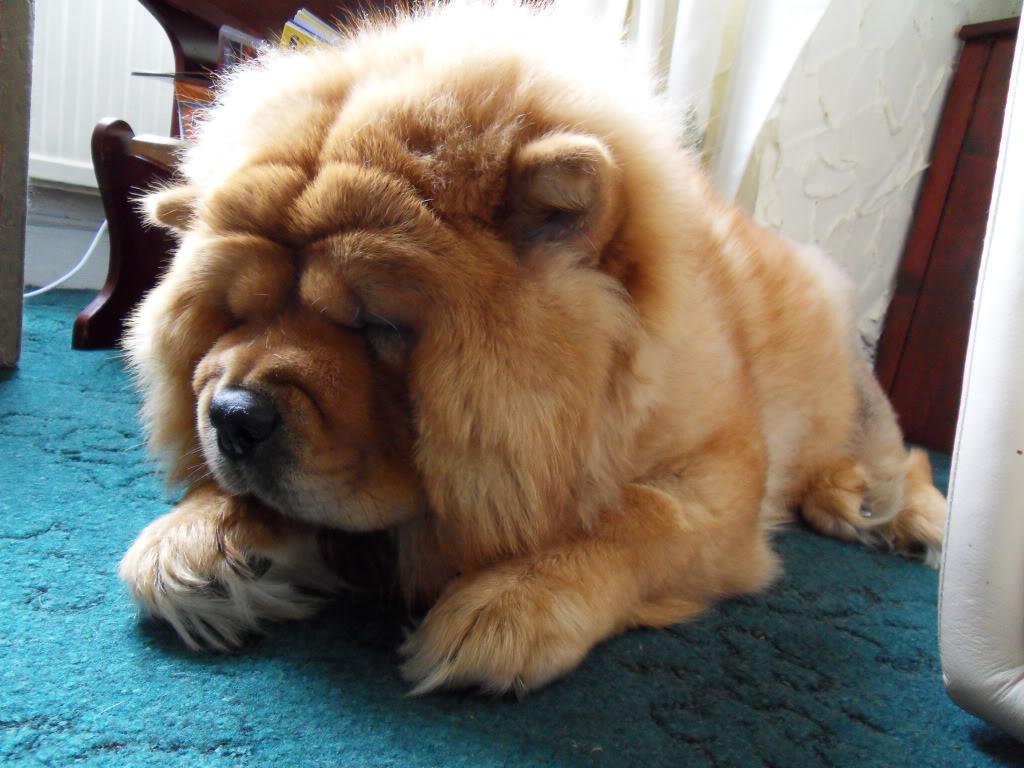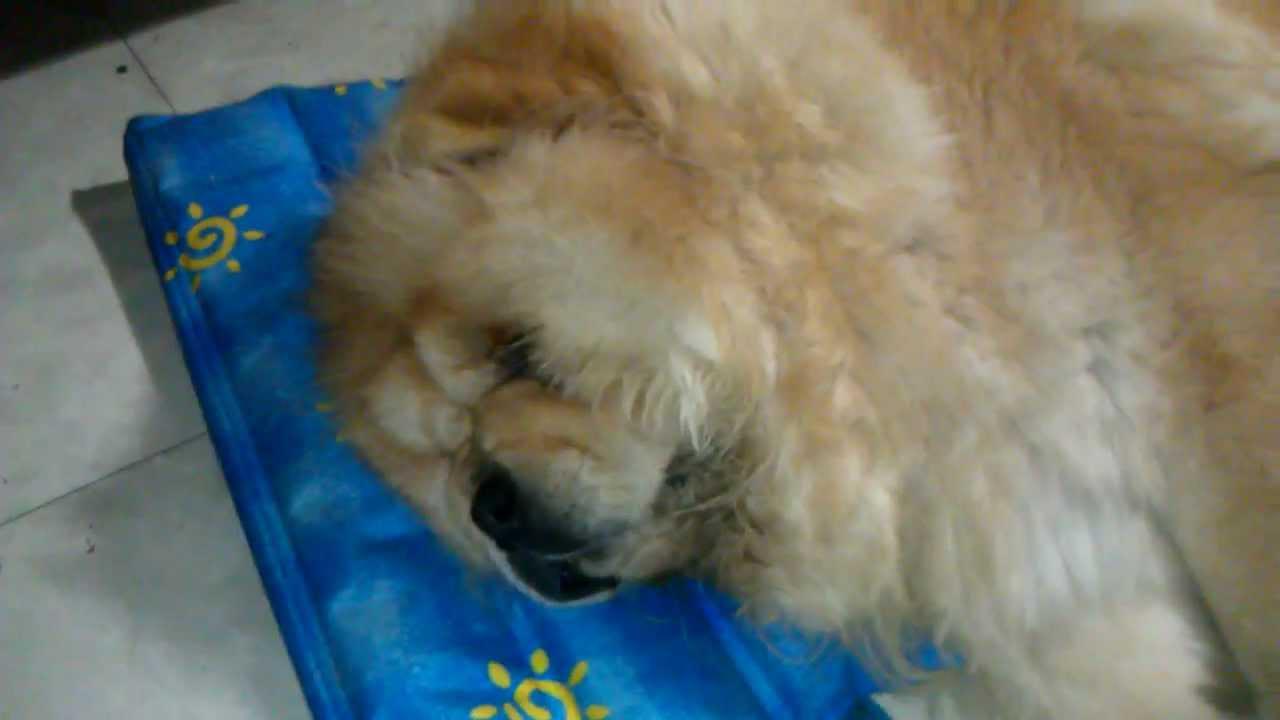The first image is the image on the left, the second image is the image on the right. Assess this claim about the two images: "The dog in the image on the left is sleeping on the tiled surface.". Correct or not? Answer yes or no. No. The first image is the image on the left, the second image is the image on the right. Assess this claim about the two images: "An image shows a chow dog sleeping up off the ground, on some type of seat.". Correct or not? Answer yes or no. No. 